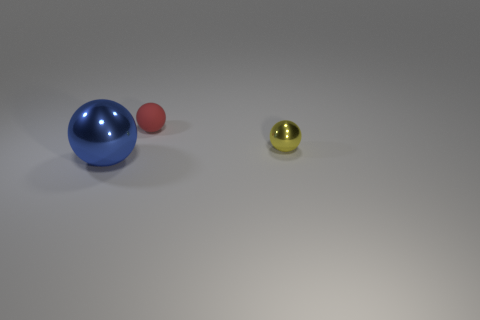Subtract all tiny matte spheres. How many spheres are left? 2 Add 2 large red metallic cylinders. How many objects exist? 5 Subtract all red spheres. How many spheres are left? 2 Subtract 2 spheres. How many spheres are left? 1 Add 2 yellow objects. How many yellow objects are left? 3 Add 3 tiny yellow objects. How many tiny yellow objects exist? 4 Subtract 1 red balls. How many objects are left? 2 Subtract all cyan spheres. Subtract all brown blocks. How many spheres are left? 3 Subtract all balls. Subtract all blue shiny blocks. How many objects are left? 0 